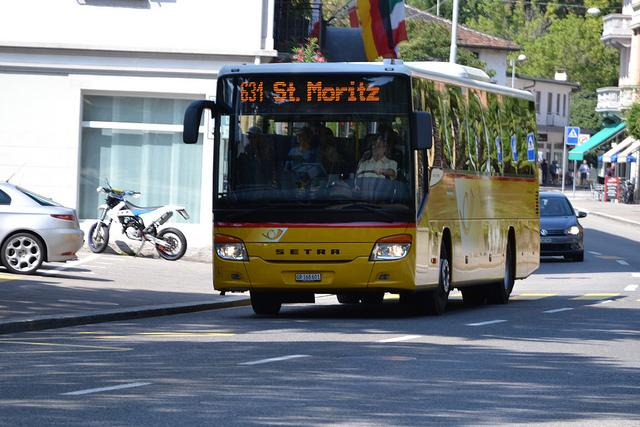What is the speed limit of school bus?

Choices:
A) 60mph
B) 75mph
C) 70mph
D) 50mph 50mph 